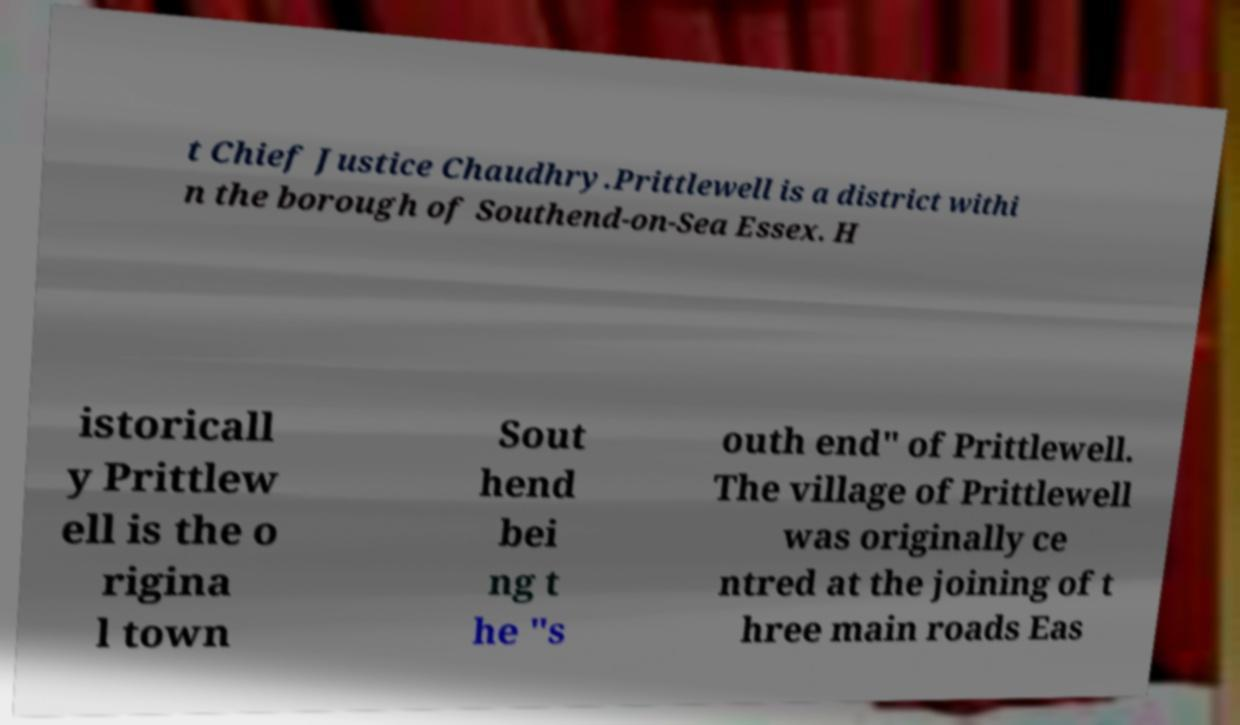Can you accurately transcribe the text from the provided image for me? t Chief Justice Chaudhry.Prittlewell is a district withi n the borough of Southend-on-Sea Essex. H istoricall y Prittlew ell is the o rigina l town Sout hend bei ng t he "s outh end" of Prittlewell. The village of Prittlewell was originally ce ntred at the joining of t hree main roads Eas 